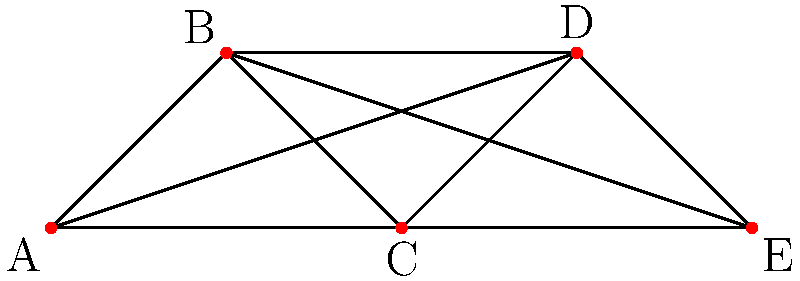As a coworker who appreciates the postal worker's dedication, you've been asked to help optimize the scheduling of postal shifts. The graph above represents conflicts between workers, where each vertex is a worker and an edge between two vertices indicates they cannot work the same shift. What is the minimum number of shifts needed to schedule all workers without conflicts? To solve this problem, we need to use graph coloring:

1. Observe that the graph is a complete graph $K_5$, where every vertex is connected to every other vertex.

2. In graph coloring, each color represents a shift, and connected vertices must have different colors (shifts).

3. For a complete graph $K_n$, the chromatic number (minimum number of colors needed) is always $n$.

4. In this case, $n = 5$, so we need 5 different colors (shifts).

5. This means each worker must be assigned to a different shift to avoid conflicts.

6. The chromatic number of 5 ensures that no two connected workers (which is all pairs in this case) will have the same shift.

Therefore, the minimum number of shifts needed is 5, equal to the number of workers.
Answer: 5 shifts 